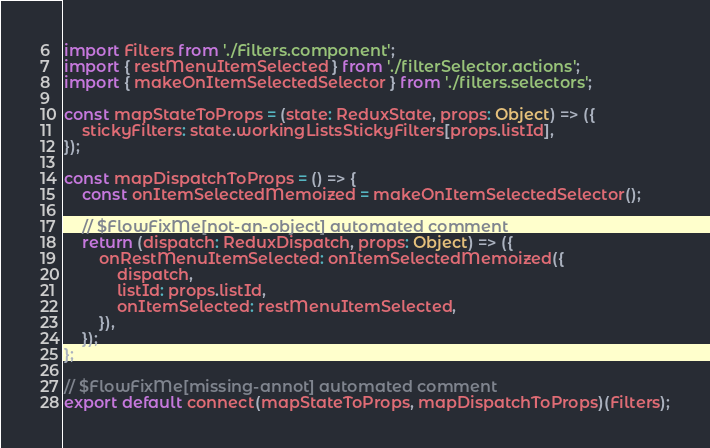Convert code to text. <code><loc_0><loc_0><loc_500><loc_500><_JavaScript_>import Filters from './Filters.component';
import { restMenuItemSelected } from './filterSelector.actions';
import { makeOnItemSelectedSelector } from './filters.selectors';

const mapStateToProps = (state: ReduxState, props: Object) => ({
    stickyFilters: state.workingListsStickyFilters[props.listId],
});

const mapDispatchToProps = () => {
    const onItemSelectedMemoized = makeOnItemSelectedSelector();

    // $FlowFixMe[not-an-object] automated comment
    return (dispatch: ReduxDispatch, props: Object) => ({
        onRestMenuItemSelected: onItemSelectedMemoized({
            dispatch,
            listId: props.listId,
            onItemSelected: restMenuItemSelected,
        }),
    });
};

// $FlowFixMe[missing-annot] automated comment
export default connect(mapStateToProps, mapDispatchToProps)(Filters);
</code> 